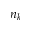Convert formula to latex. <formula><loc_0><loc_0><loc_500><loc_500>n _ { k }</formula> 